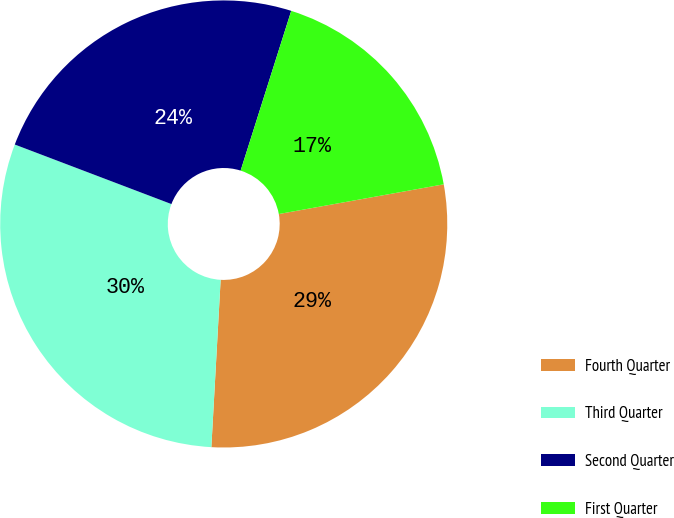Convert chart. <chart><loc_0><loc_0><loc_500><loc_500><pie_chart><fcel>Fourth Quarter<fcel>Third Quarter<fcel>Second Quarter<fcel>First Quarter<nl><fcel>28.72%<fcel>29.9%<fcel>24.1%<fcel>17.28%<nl></chart> 